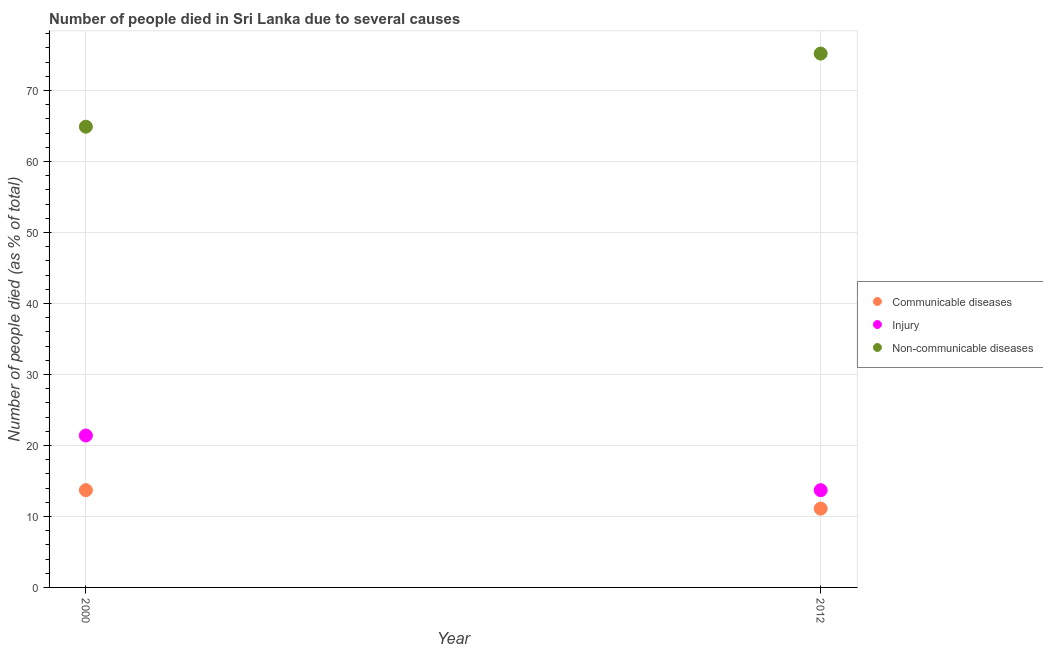Across all years, what is the minimum number of people who dies of non-communicable diseases?
Ensure brevity in your answer.  64.9. In which year was the number of people who dies of non-communicable diseases maximum?
Give a very brief answer. 2012. In which year was the number of people who died of communicable diseases minimum?
Provide a succinct answer. 2012. What is the total number of people who dies of non-communicable diseases in the graph?
Give a very brief answer. 140.1. What is the difference between the number of people who died of communicable diseases in 2000 and that in 2012?
Give a very brief answer. 2.6. What is the difference between the number of people who dies of non-communicable diseases in 2012 and the number of people who died of injury in 2000?
Provide a succinct answer. 53.8. What is the average number of people who died of communicable diseases per year?
Ensure brevity in your answer.  12.4. In the year 2012, what is the difference between the number of people who died of injury and number of people who dies of non-communicable diseases?
Your answer should be compact. -61.5. In how many years, is the number of people who died of injury greater than 32 %?
Provide a succinct answer. 0. What is the ratio of the number of people who died of injury in 2000 to that in 2012?
Offer a terse response. 1.56. Is it the case that in every year, the sum of the number of people who died of communicable diseases and number of people who died of injury is greater than the number of people who dies of non-communicable diseases?
Make the answer very short. No. Is the number of people who died of communicable diseases strictly less than the number of people who dies of non-communicable diseases over the years?
Give a very brief answer. Yes. How many dotlines are there?
Make the answer very short. 3. Does the graph contain any zero values?
Keep it short and to the point. No. How are the legend labels stacked?
Your response must be concise. Vertical. What is the title of the graph?
Offer a terse response. Number of people died in Sri Lanka due to several causes. Does "Primary" appear as one of the legend labels in the graph?
Offer a terse response. No. What is the label or title of the Y-axis?
Your answer should be compact. Number of people died (as % of total). What is the Number of people died (as % of total) of Communicable diseases in 2000?
Make the answer very short. 13.7. What is the Number of people died (as % of total) in Injury in 2000?
Offer a very short reply. 21.4. What is the Number of people died (as % of total) in Non-communicable diseases in 2000?
Provide a succinct answer. 64.9. What is the Number of people died (as % of total) of Communicable diseases in 2012?
Provide a short and direct response. 11.1. What is the Number of people died (as % of total) in Non-communicable diseases in 2012?
Your response must be concise. 75.2. Across all years, what is the maximum Number of people died (as % of total) of Injury?
Ensure brevity in your answer.  21.4. Across all years, what is the maximum Number of people died (as % of total) of Non-communicable diseases?
Make the answer very short. 75.2. Across all years, what is the minimum Number of people died (as % of total) in Injury?
Your answer should be compact. 13.7. Across all years, what is the minimum Number of people died (as % of total) of Non-communicable diseases?
Your response must be concise. 64.9. What is the total Number of people died (as % of total) of Communicable diseases in the graph?
Ensure brevity in your answer.  24.8. What is the total Number of people died (as % of total) of Injury in the graph?
Your answer should be compact. 35.1. What is the total Number of people died (as % of total) of Non-communicable diseases in the graph?
Give a very brief answer. 140.1. What is the difference between the Number of people died (as % of total) in Communicable diseases in 2000 and the Number of people died (as % of total) in Non-communicable diseases in 2012?
Make the answer very short. -61.5. What is the difference between the Number of people died (as % of total) in Injury in 2000 and the Number of people died (as % of total) in Non-communicable diseases in 2012?
Give a very brief answer. -53.8. What is the average Number of people died (as % of total) of Injury per year?
Provide a short and direct response. 17.55. What is the average Number of people died (as % of total) in Non-communicable diseases per year?
Offer a very short reply. 70.05. In the year 2000, what is the difference between the Number of people died (as % of total) in Communicable diseases and Number of people died (as % of total) in Non-communicable diseases?
Keep it short and to the point. -51.2. In the year 2000, what is the difference between the Number of people died (as % of total) of Injury and Number of people died (as % of total) of Non-communicable diseases?
Provide a succinct answer. -43.5. In the year 2012, what is the difference between the Number of people died (as % of total) of Communicable diseases and Number of people died (as % of total) of Non-communicable diseases?
Give a very brief answer. -64.1. In the year 2012, what is the difference between the Number of people died (as % of total) of Injury and Number of people died (as % of total) of Non-communicable diseases?
Keep it short and to the point. -61.5. What is the ratio of the Number of people died (as % of total) in Communicable diseases in 2000 to that in 2012?
Keep it short and to the point. 1.23. What is the ratio of the Number of people died (as % of total) in Injury in 2000 to that in 2012?
Give a very brief answer. 1.56. What is the ratio of the Number of people died (as % of total) of Non-communicable diseases in 2000 to that in 2012?
Keep it short and to the point. 0.86. What is the difference between the highest and the second highest Number of people died (as % of total) in Injury?
Offer a very short reply. 7.7. What is the difference between the highest and the lowest Number of people died (as % of total) in Communicable diseases?
Offer a terse response. 2.6. What is the difference between the highest and the lowest Number of people died (as % of total) in Injury?
Ensure brevity in your answer.  7.7. What is the difference between the highest and the lowest Number of people died (as % of total) in Non-communicable diseases?
Your answer should be compact. 10.3. 